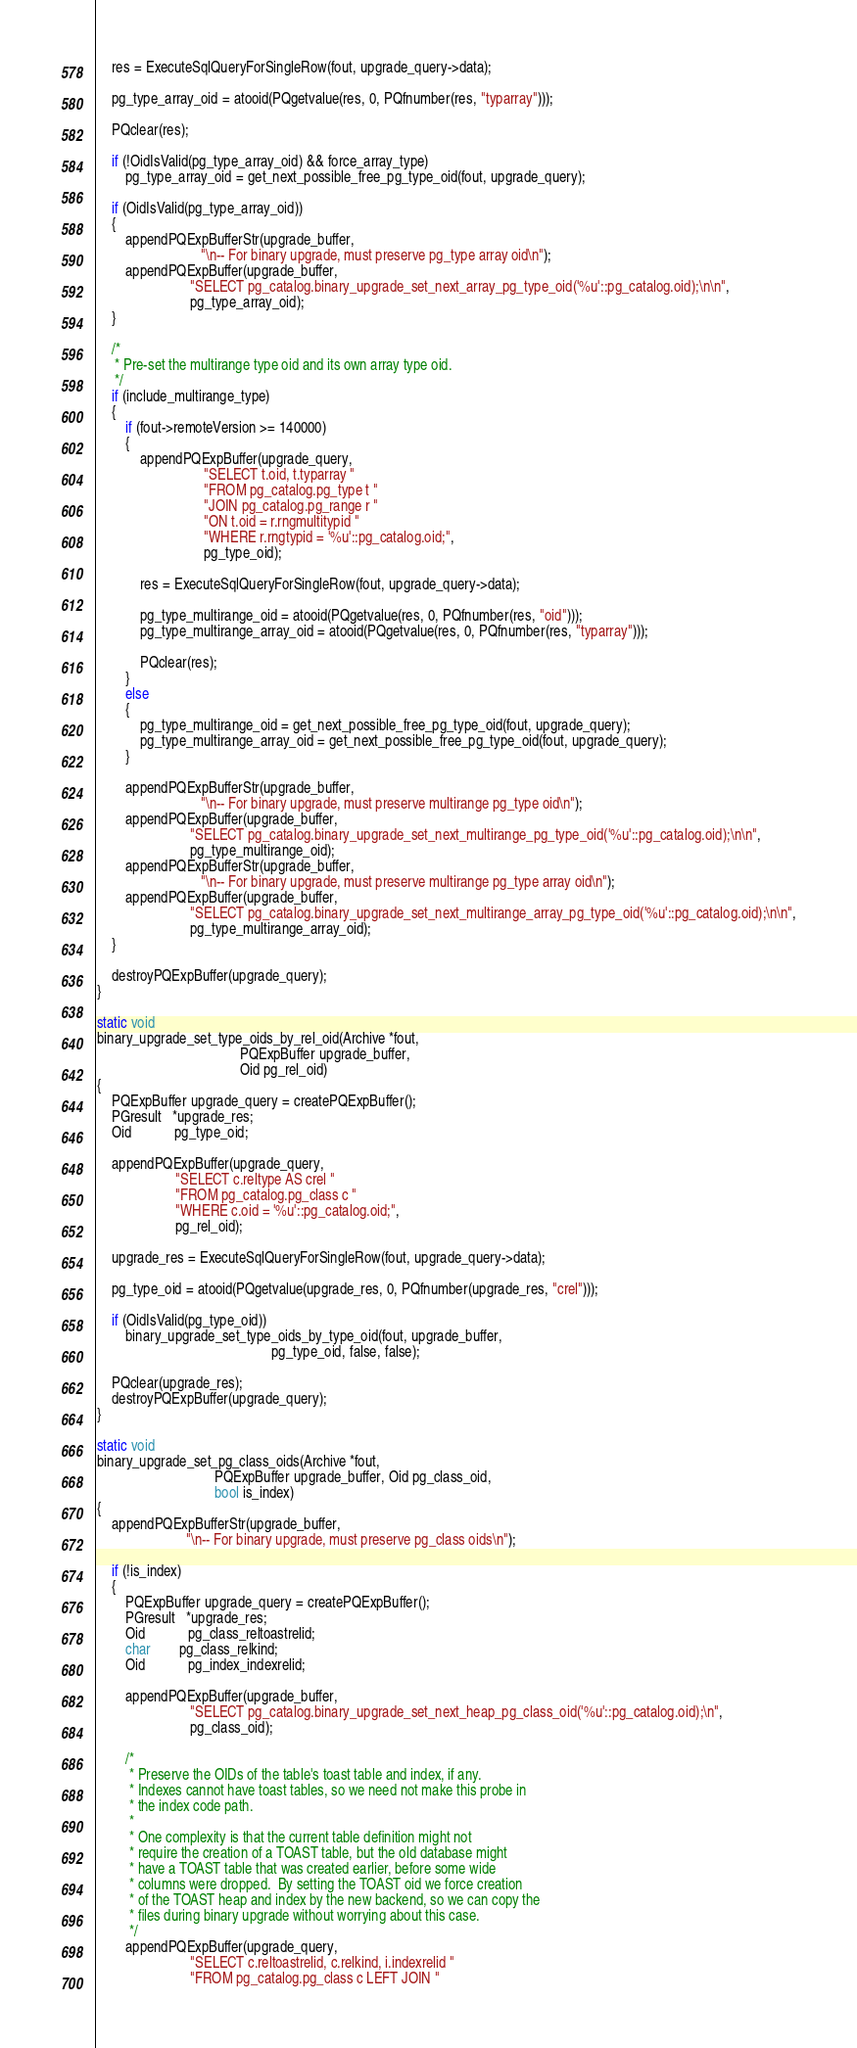Convert code to text. <code><loc_0><loc_0><loc_500><loc_500><_C_>
	res = ExecuteSqlQueryForSingleRow(fout, upgrade_query->data);

	pg_type_array_oid = atooid(PQgetvalue(res, 0, PQfnumber(res, "typarray")));

	PQclear(res);

	if (!OidIsValid(pg_type_array_oid) && force_array_type)
		pg_type_array_oid = get_next_possible_free_pg_type_oid(fout, upgrade_query);

	if (OidIsValid(pg_type_array_oid))
	{
		appendPQExpBufferStr(upgrade_buffer,
							 "\n-- For binary upgrade, must preserve pg_type array oid\n");
		appendPQExpBuffer(upgrade_buffer,
						  "SELECT pg_catalog.binary_upgrade_set_next_array_pg_type_oid('%u'::pg_catalog.oid);\n\n",
						  pg_type_array_oid);
	}

	/*
	 * Pre-set the multirange type oid and its own array type oid.
	 */
	if (include_multirange_type)
	{
		if (fout->remoteVersion >= 140000)
		{
			appendPQExpBuffer(upgrade_query,
							  "SELECT t.oid, t.typarray "
							  "FROM pg_catalog.pg_type t "
							  "JOIN pg_catalog.pg_range r "
							  "ON t.oid = r.rngmultitypid "
							  "WHERE r.rngtypid = '%u'::pg_catalog.oid;",
							  pg_type_oid);

			res = ExecuteSqlQueryForSingleRow(fout, upgrade_query->data);

			pg_type_multirange_oid = atooid(PQgetvalue(res, 0, PQfnumber(res, "oid")));
			pg_type_multirange_array_oid = atooid(PQgetvalue(res, 0, PQfnumber(res, "typarray")));

			PQclear(res);
		}
		else
		{
			pg_type_multirange_oid = get_next_possible_free_pg_type_oid(fout, upgrade_query);
			pg_type_multirange_array_oid = get_next_possible_free_pg_type_oid(fout, upgrade_query);
		}

		appendPQExpBufferStr(upgrade_buffer,
							 "\n-- For binary upgrade, must preserve multirange pg_type oid\n");
		appendPQExpBuffer(upgrade_buffer,
						  "SELECT pg_catalog.binary_upgrade_set_next_multirange_pg_type_oid('%u'::pg_catalog.oid);\n\n",
						  pg_type_multirange_oid);
		appendPQExpBufferStr(upgrade_buffer,
							 "\n-- For binary upgrade, must preserve multirange pg_type array oid\n");
		appendPQExpBuffer(upgrade_buffer,
						  "SELECT pg_catalog.binary_upgrade_set_next_multirange_array_pg_type_oid('%u'::pg_catalog.oid);\n\n",
						  pg_type_multirange_array_oid);
	}

	destroyPQExpBuffer(upgrade_query);
}

static void
binary_upgrade_set_type_oids_by_rel_oid(Archive *fout,
										PQExpBuffer upgrade_buffer,
										Oid pg_rel_oid)
{
	PQExpBuffer upgrade_query = createPQExpBuffer();
	PGresult   *upgrade_res;
	Oid			pg_type_oid;

	appendPQExpBuffer(upgrade_query,
					  "SELECT c.reltype AS crel "
					  "FROM pg_catalog.pg_class c "
					  "WHERE c.oid = '%u'::pg_catalog.oid;",
					  pg_rel_oid);

	upgrade_res = ExecuteSqlQueryForSingleRow(fout, upgrade_query->data);

	pg_type_oid = atooid(PQgetvalue(upgrade_res, 0, PQfnumber(upgrade_res, "crel")));

	if (OidIsValid(pg_type_oid))
		binary_upgrade_set_type_oids_by_type_oid(fout, upgrade_buffer,
												 pg_type_oid, false, false);

	PQclear(upgrade_res);
	destroyPQExpBuffer(upgrade_query);
}

static void
binary_upgrade_set_pg_class_oids(Archive *fout,
								 PQExpBuffer upgrade_buffer, Oid pg_class_oid,
								 bool is_index)
{
	appendPQExpBufferStr(upgrade_buffer,
						 "\n-- For binary upgrade, must preserve pg_class oids\n");

	if (!is_index)
	{
		PQExpBuffer upgrade_query = createPQExpBuffer();
		PGresult   *upgrade_res;
		Oid			pg_class_reltoastrelid;
		char		pg_class_relkind;
		Oid			pg_index_indexrelid;

		appendPQExpBuffer(upgrade_buffer,
						  "SELECT pg_catalog.binary_upgrade_set_next_heap_pg_class_oid('%u'::pg_catalog.oid);\n",
						  pg_class_oid);

		/*
		 * Preserve the OIDs of the table's toast table and index, if any.
		 * Indexes cannot have toast tables, so we need not make this probe in
		 * the index code path.
		 *
		 * One complexity is that the current table definition might not
		 * require the creation of a TOAST table, but the old database might
		 * have a TOAST table that was created earlier, before some wide
		 * columns were dropped.  By setting the TOAST oid we force creation
		 * of the TOAST heap and index by the new backend, so we can copy the
		 * files during binary upgrade without worrying about this case.
		 */
		appendPQExpBuffer(upgrade_query,
						  "SELECT c.reltoastrelid, c.relkind, i.indexrelid "
						  "FROM pg_catalog.pg_class c LEFT JOIN "</code> 